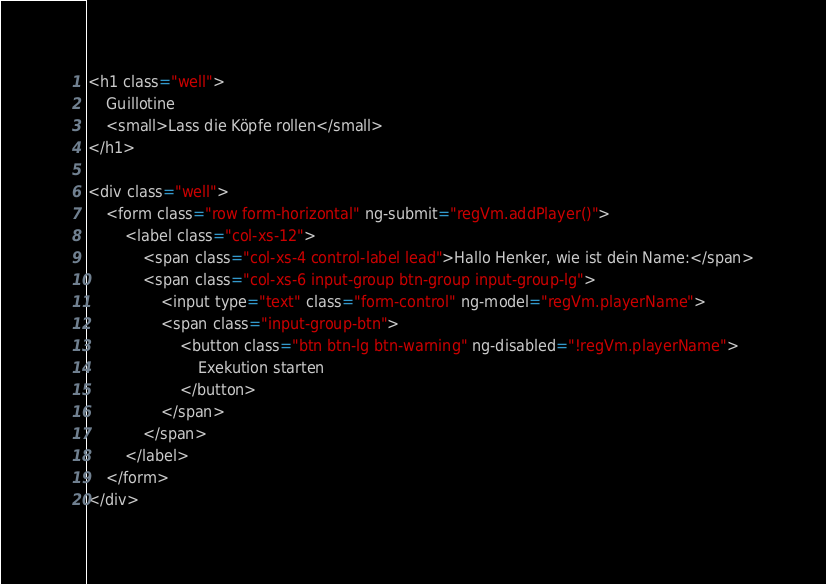Convert code to text. <code><loc_0><loc_0><loc_500><loc_500><_HTML_><h1 class="well">
    Guillotine
    <small>Lass die Köpfe rollen</small>
</h1>

<div class="well">
    <form class="row form-horizontal" ng-submit="regVm.addPlayer()">
        <label class="col-xs-12">
            <span class="col-xs-4 control-label lead">Hallo Henker, wie ist dein Name:</span>
            <span class="col-xs-6 input-group btn-group input-group-lg">
                <input type="text" class="form-control" ng-model="regVm.playerName">
                <span class="input-group-btn">
                    <button class="btn btn-lg btn-warning" ng-disabled="!regVm.playerName">
                        Exekution starten
                    </button>
                </span>
            </span>
        </label>
    </form>
</div>
</code> 